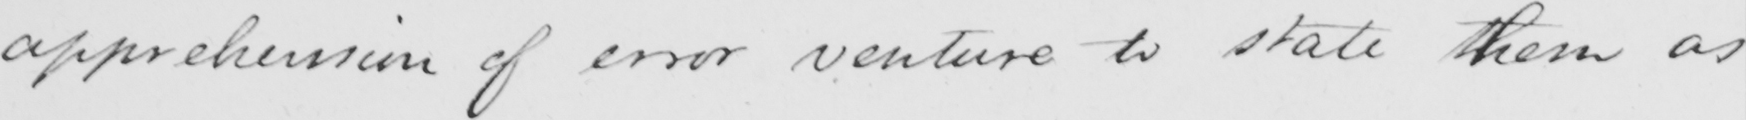What does this handwritten line say? apprehension of error venture to state them as 